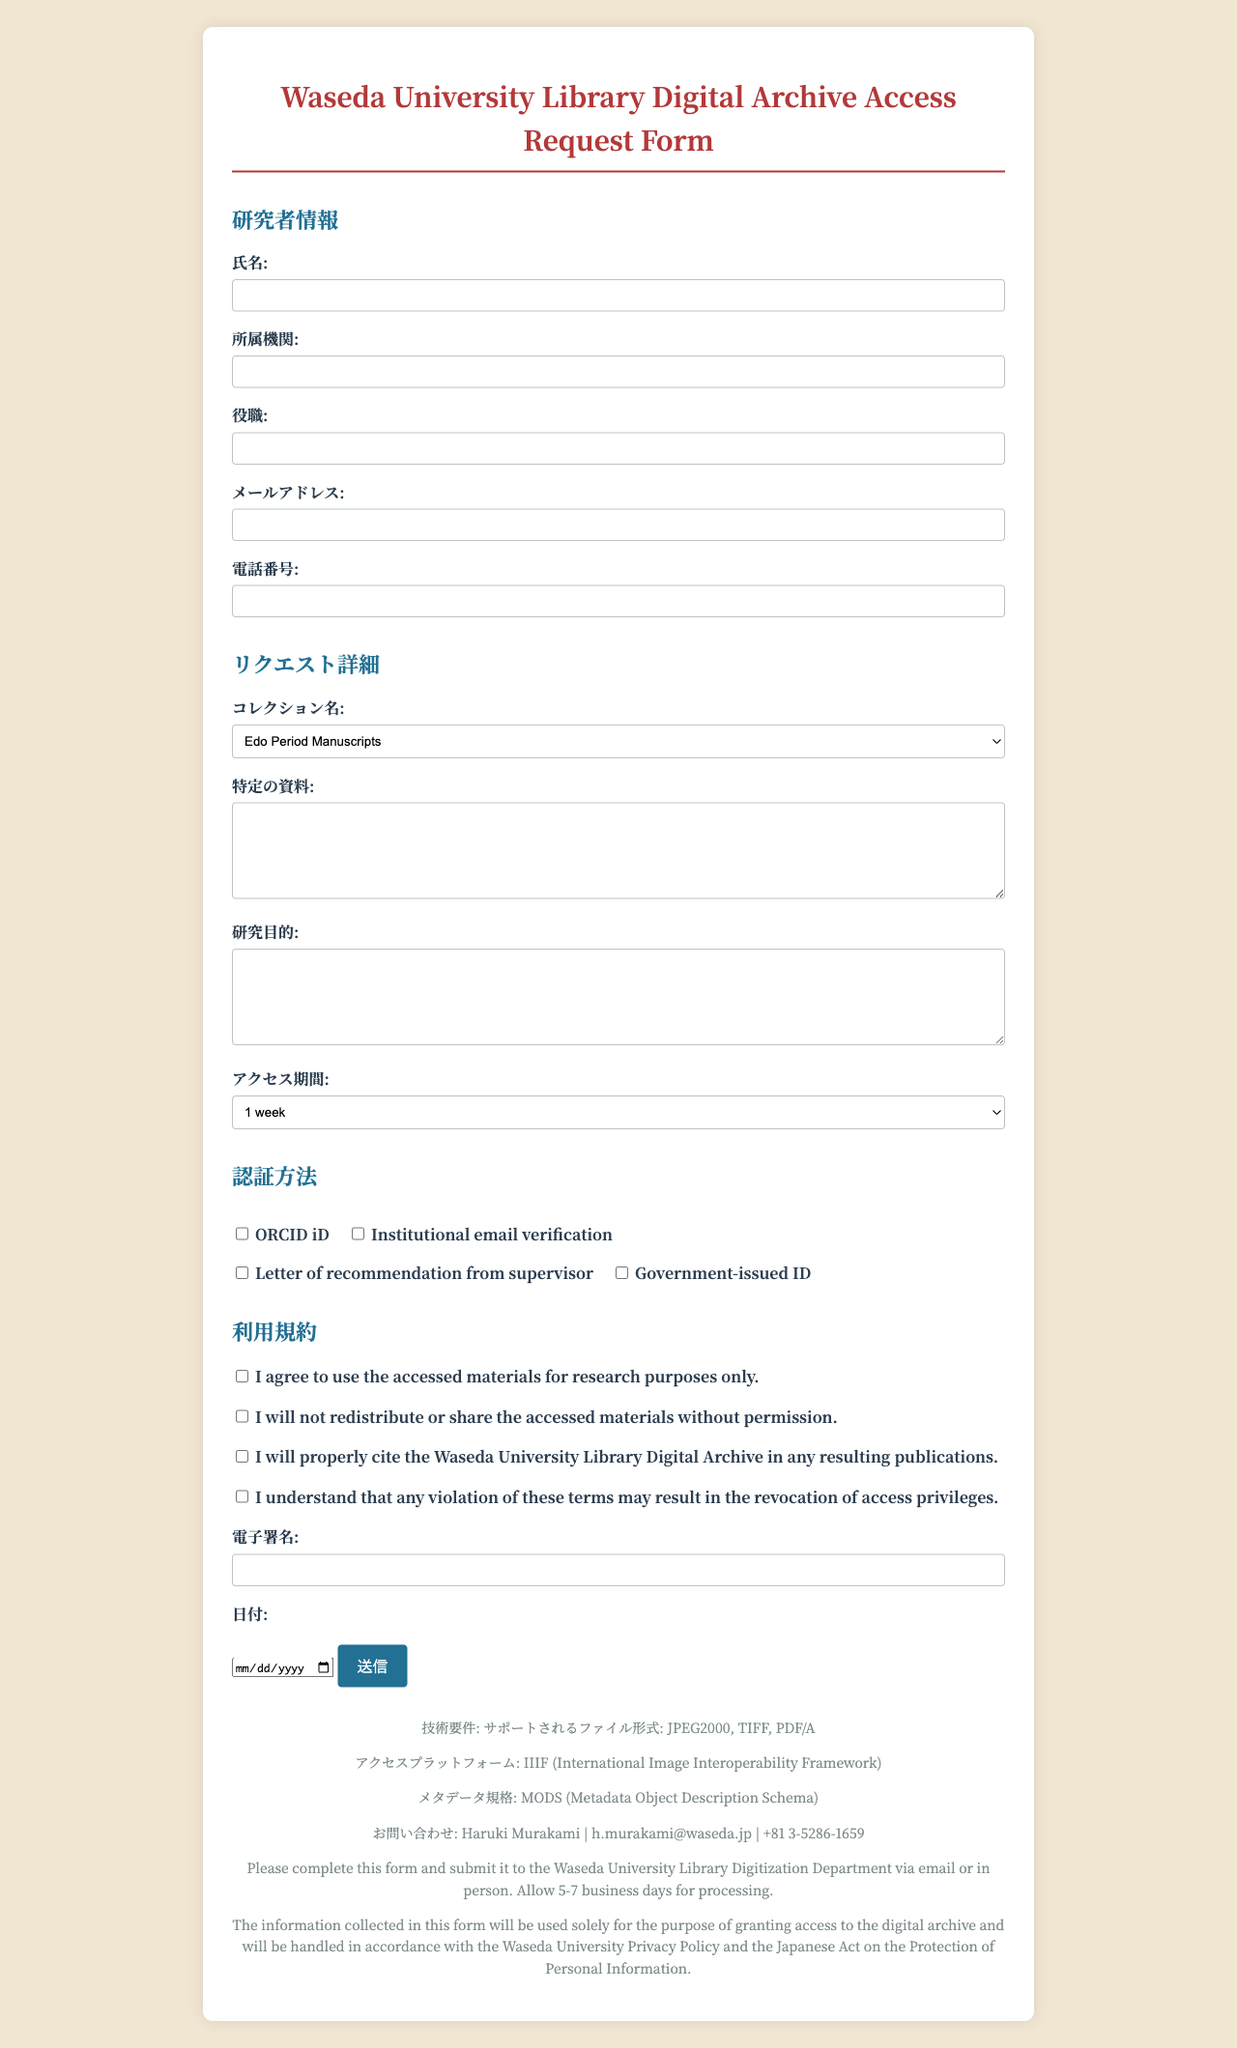What is the title of the form? The title of the form is mentioned at the top of the document, indicating its purpose.
Answer: Waseda University Library Digital Archive Access Request Form Who is the librarian to contact? The contact information section specifies the name of the librarian for inquiries.
Answer: Haruki Murakami What is the maximum access duration available? The request details section lists the options for access duration, indicating the longest period available.
Answer: 1 year What email verification method is listed for authentication? The section on authentication methods mentions multiple ways to authenticate, including one specific method.
Answer: Institutional email verification How many sections are in the usage agreement? The usage agreement section has multiple statements that the user must agree to, specifying the number of them.
Answer: 4 What is the submission instruction? The last part of the document provides guidance on how to submit the completed form.
Answer: Please complete this form and submit it to the Waseda University Library Digitization Department via email or in person. Allow 5-7 business days for processing What file format is not supported? The technical requirements section specifies the supported file formats, implying any format not mentioned is unsupported.
Answer: Not applicable (as only supported formats are listed) What is the privacy statement about? The privacy statement elaborates on how the collected information will be used, reflecting its purpose.
Answer: The information collected in this form will be used solely for the purpose of granting access to the digital archive and will be handled in accordance with the Waseda University Privacy Policy and the Japanese Act on the Protection of Personal Information 